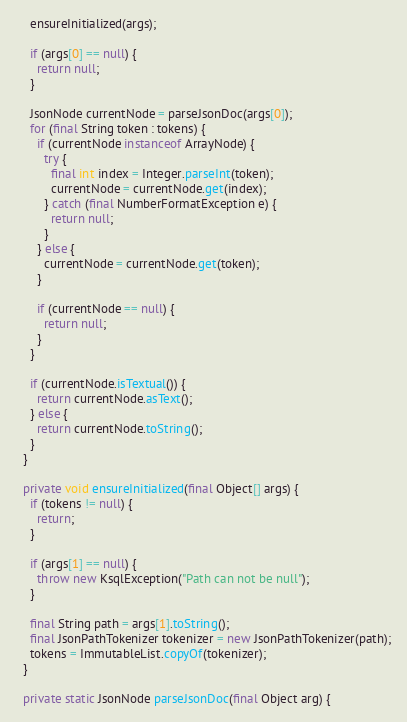Convert code to text. <code><loc_0><loc_0><loc_500><loc_500><_Java_>
    ensureInitialized(args);

    if (args[0] == null) {
      return null;
    }

    JsonNode currentNode = parseJsonDoc(args[0]);
    for (final String token : tokens) {
      if (currentNode instanceof ArrayNode) {
        try {
          final int index = Integer.parseInt(token);
          currentNode = currentNode.get(index);
        } catch (final NumberFormatException e) {
          return null;
        }
      } else {
        currentNode = currentNode.get(token);
      }

      if (currentNode == null) {
        return null;
      }
    }

    if (currentNode.isTextual()) {
      return currentNode.asText();
    } else {
      return currentNode.toString();
    }
  }

  private void ensureInitialized(final Object[] args) {
    if (tokens != null) {
      return;
    }

    if (args[1] == null) {
      throw new KsqlException("Path can not be null");
    }

    final String path = args[1].toString();
    final JsonPathTokenizer tokenizer = new JsonPathTokenizer(path);
    tokens = ImmutableList.copyOf(tokenizer);
  }

  private static JsonNode parseJsonDoc(final Object arg) {</code> 